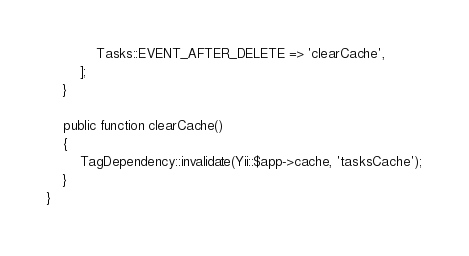<code> <loc_0><loc_0><loc_500><loc_500><_PHP_>			Tasks::EVENT_AFTER_DELETE => 'clearCache',
		];
	}

	public function clearCache()
	{
		TagDependency::invalidate(Yii::$app->cache, 'tasksCache');
	}
}</code> 